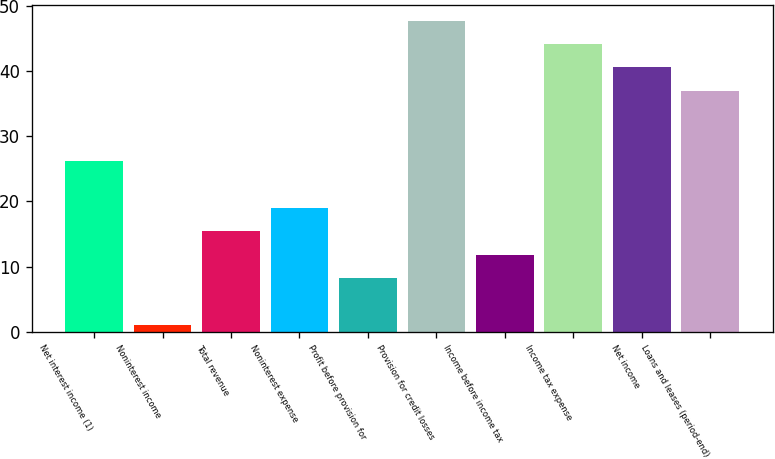<chart> <loc_0><loc_0><loc_500><loc_500><bar_chart><fcel>Net interest income (1)<fcel>Noninterest income<fcel>Total revenue<fcel>Noninterest expense<fcel>Profit before provision for<fcel>Provision for credit losses<fcel>Income before income tax<fcel>Income tax expense<fcel>Net income<fcel>Loans and leases (period-end)<nl><fcel>26.2<fcel>1<fcel>15.4<fcel>19<fcel>8.2<fcel>47.8<fcel>11.8<fcel>44.2<fcel>40.6<fcel>37<nl></chart> 